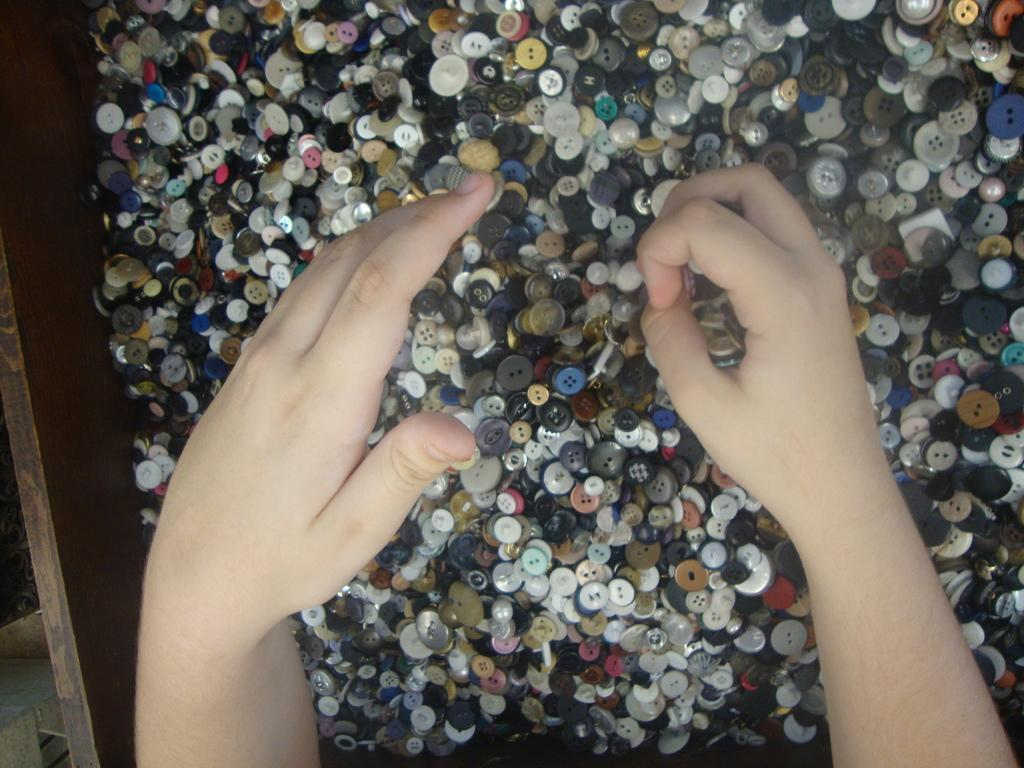What object is made of wood in the picture? There is a wooden box in the picture. What is inside the wooden box? There are buttons in the wooden box. Whose hands are visible in the picture? Human hands are visible in the picture. What type of texture does the girl's dress have in the image? There is no girl present in the image, so we cannot determine the texture of her dress. 